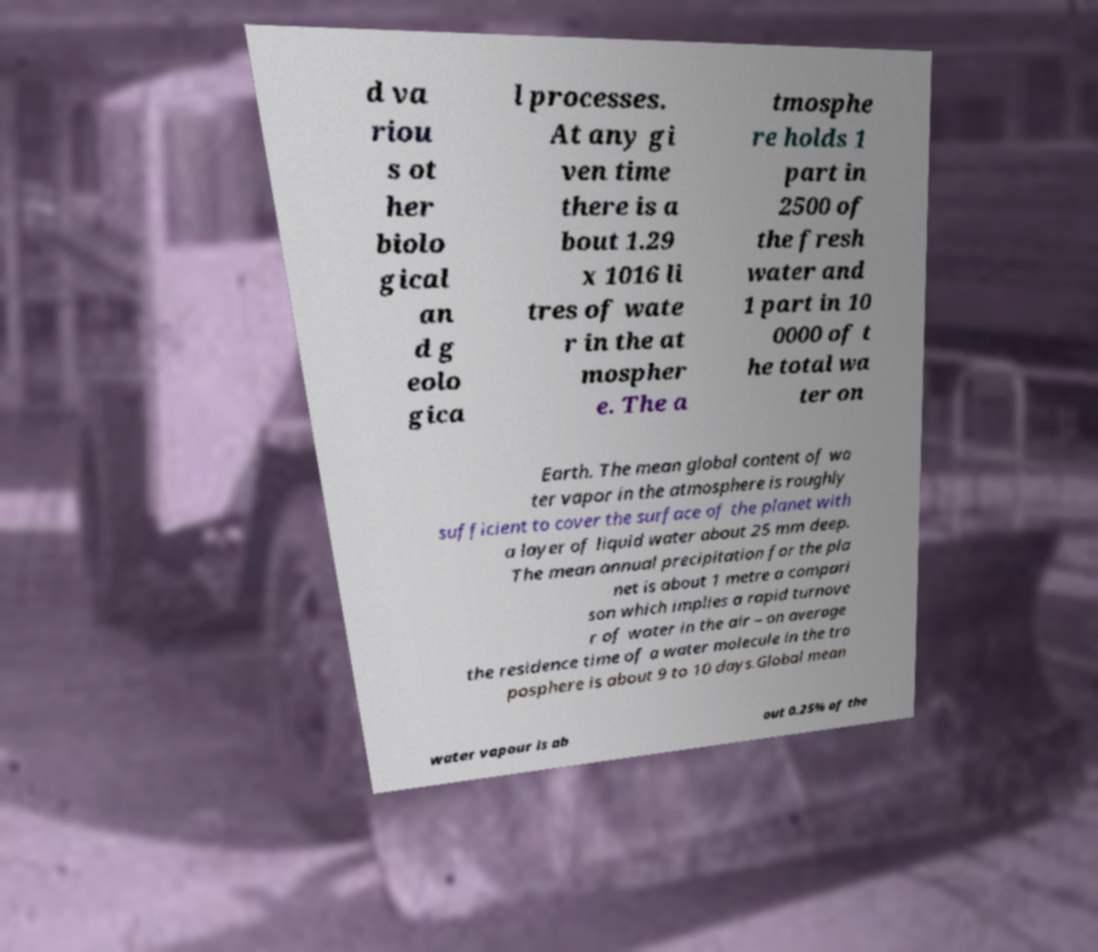For documentation purposes, I need the text within this image transcribed. Could you provide that? d va riou s ot her biolo gical an d g eolo gica l processes. At any gi ven time there is a bout 1.29 x 1016 li tres of wate r in the at mospher e. The a tmosphe re holds 1 part in 2500 of the fresh water and 1 part in 10 0000 of t he total wa ter on Earth. The mean global content of wa ter vapor in the atmosphere is roughly sufficient to cover the surface of the planet with a layer of liquid water about 25 mm deep. The mean annual precipitation for the pla net is about 1 metre a compari son which implies a rapid turnove r of water in the air – on average the residence time of a water molecule in the tro posphere is about 9 to 10 days.Global mean water vapour is ab out 0.25% of the 